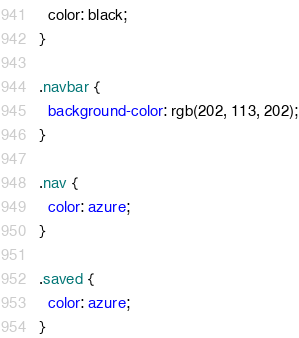<code> <loc_0><loc_0><loc_500><loc_500><_CSS_>  color: black;
}

.navbar {
  background-color: rgb(202, 113, 202);
}

.nav {
  color: azure;
}

.saved {
  color: azure;
}</code> 